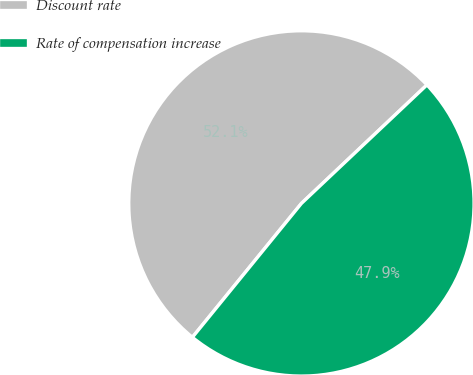Convert chart to OTSL. <chart><loc_0><loc_0><loc_500><loc_500><pie_chart><fcel>Discount rate<fcel>Rate of compensation increase<nl><fcel>52.08%<fcel>47.92%<nl></chart> 